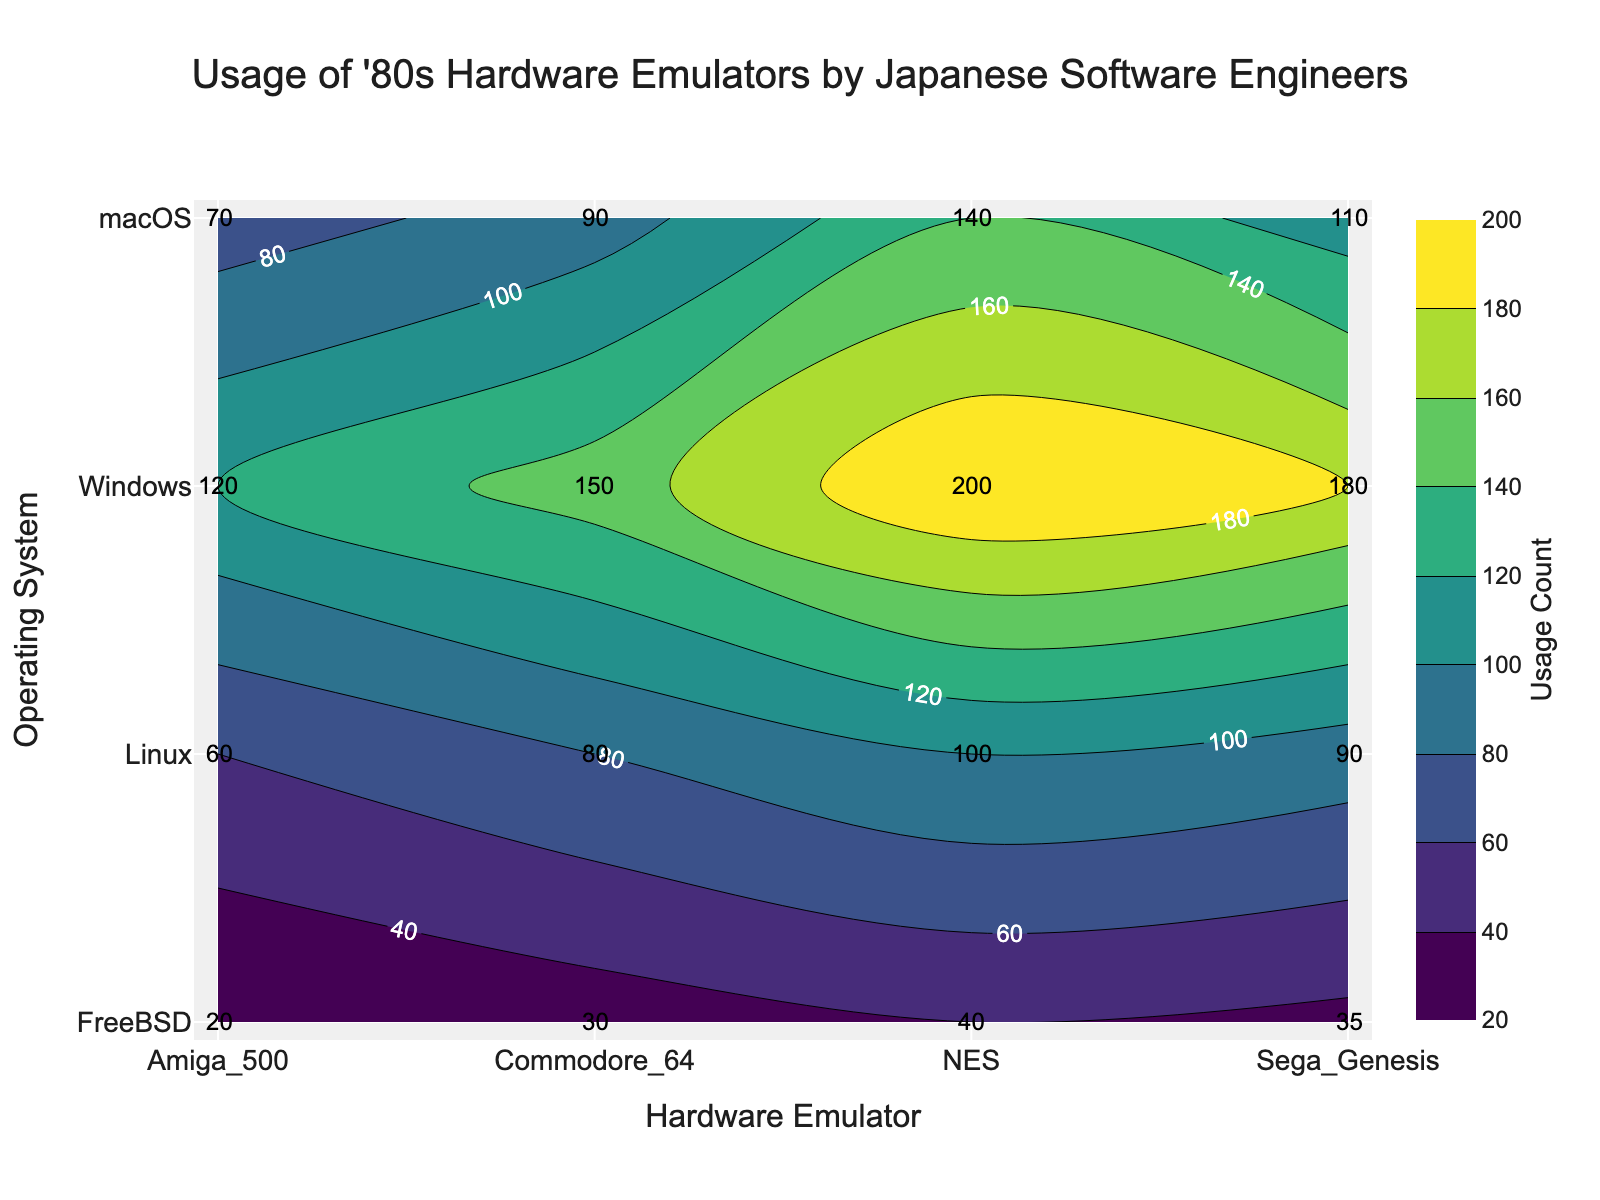What's the title of the plot? The title of the plot is displayed at the top center. It reads, "Usage of '80s Hardware Emulators by Japanese Software Engineers."
Answer: Usage of '80s Hardware Emulators by Japanese Software Engineers Which operating system shows the highest usage count for the NES emulator? By referring to the y-axis for Operating Systems and the x-axis for the NES column, the contour label with the highest value under NES belongs to Windows with a usage count of 200.
Answer: Windows How many hardware emulators have a usage count of more than 100 on macOS? By examining the contour labels corresponding to macOS on the plot, Commodore 64, NES, and Sega Genesis all have a usage count greater than 100.
Answer: 3 Which hardware emulator has the lowest usage count on FreeBSD? By referring to the contour labels for FreeBSD along the y-axis and scanning across the x-axis for all hardware emulators, Amiga 500 has the lowest usage count with a value of 20.
Answer: Amiga 500 What is the combined usage count of the NES emulator across all operating systems? To calculate the combined usage count for the NES emulator, sum up the contour labels under the NES column from all rows: 200 (Windows) + 140 (macOS) + 100 (Linux) + 40 (FreeBSD). The combined usage count is 480.
Answer: 480 Compare the usage counts of Commodore 64 emulators between Windows and Linux operating systems. Which one is higher and by how much? By checking the contour labels for Commodore 64 under both Windows and Linux rows, the usage counts are 150 (Windows) and 80 (Linux). Thus, Windows has a higher usage count by 150 - 80 = 70.
Answer: Windows by 70 Which two operating systems have the closest usage counts for the Amiga 500 emulator? By examining the contour labels for Amiga 500 on the plot across all operating systems, the closest values are 70 (macOS) and 60 (Linux), which differ by only 10 units.
Answer: macOS and Linux Is there an operating system where no hardware emulator has a usage count below 100? By examining the contour labels across all hardware emulators for each operating system, Windows is the only operating system where all usage counts (150, 120, 200, 180) are 100 or above.
Answer: Yes, Windows What is the average usage count for Sega Genesis across all operating systems? To calculate the average, first sum the usage counts for Sega Genesis across all operating systems: 180 (Windows) + 110 (macOS) + 90 (Linux) + 35 (FreeBSD) = 415. Divide by the number of operating systems, which is 4. The average is 415 / 4 = 103.75.
Answer: 103.75 